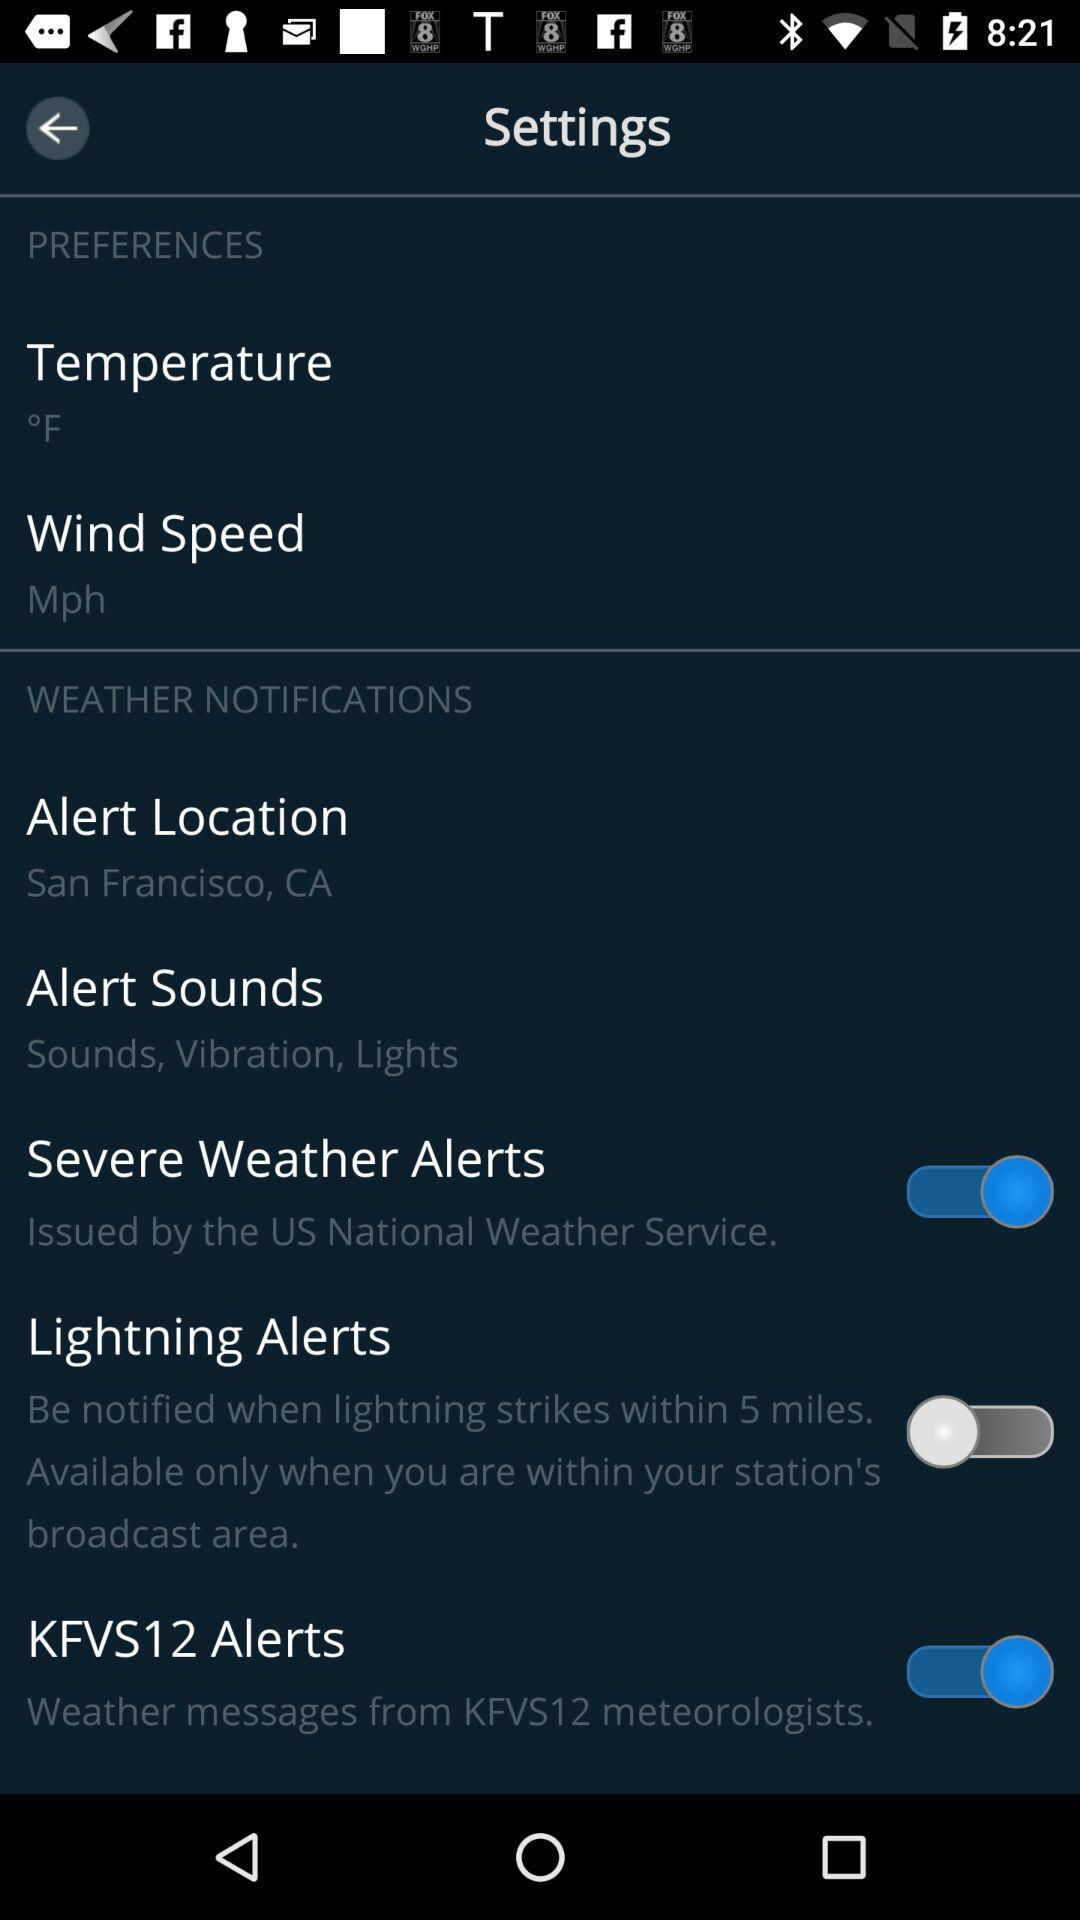What is the current status of "KFVS12 Alerts"? The current status is "on". 